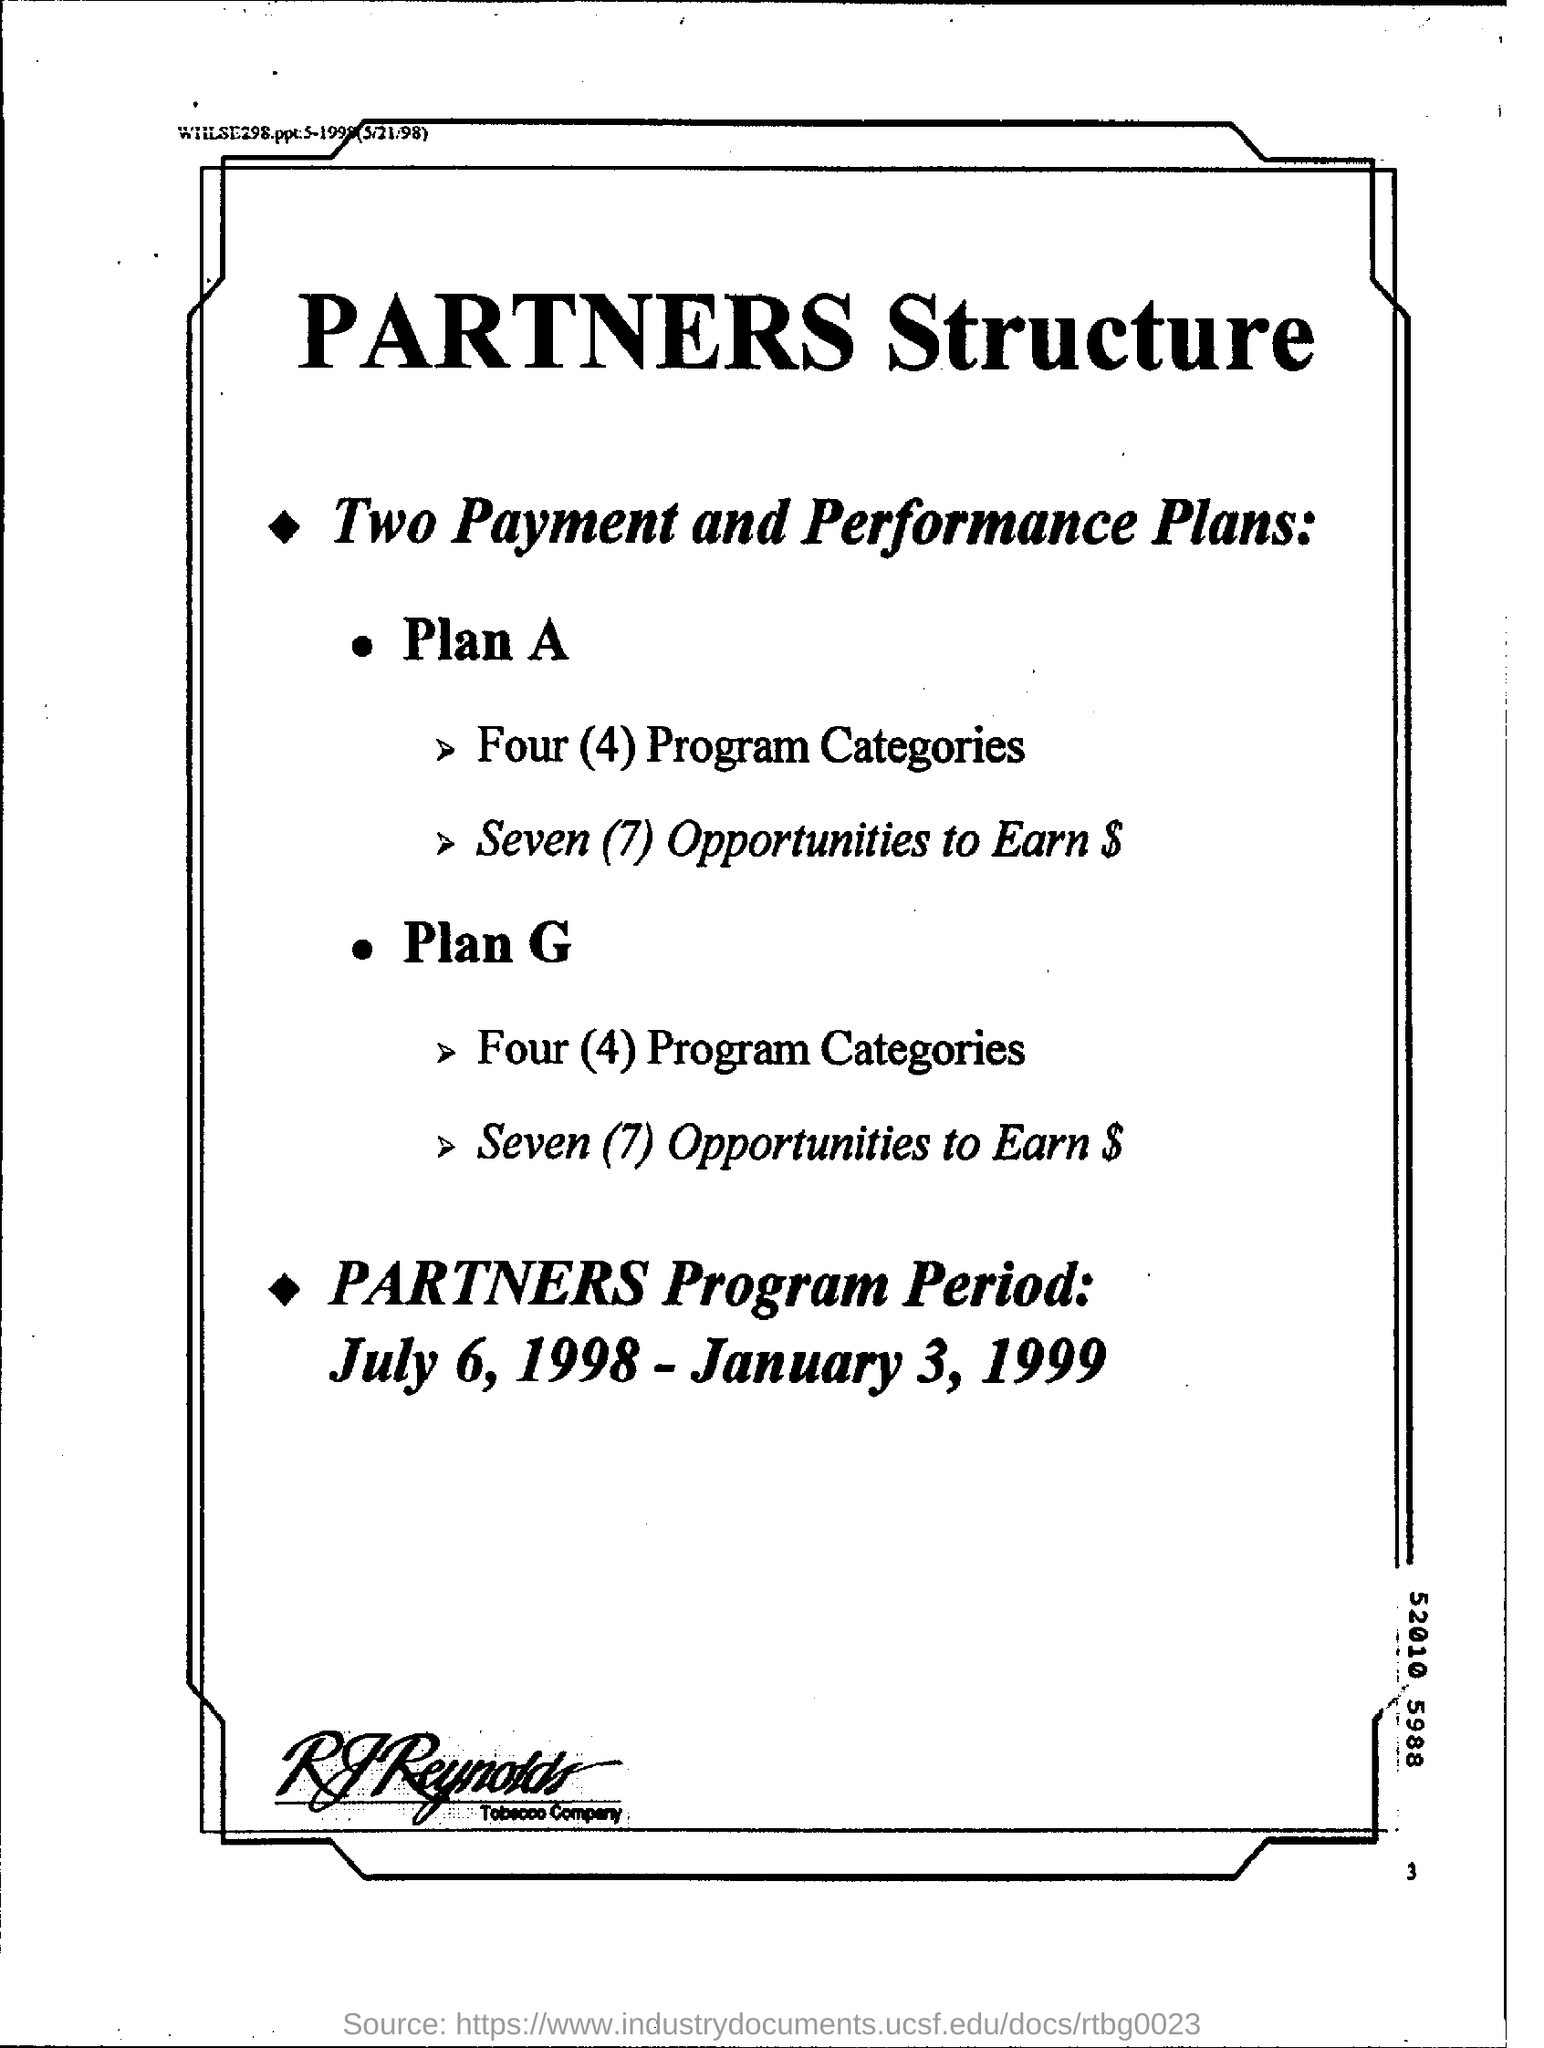How many payment and performance plans are there ?
Provide a succinct answer. Two. What is the number of program categories under plan g?
Offer a terse response. 4. What is the partners program period?
Ensure brevity in your answer.  July 6, 1998 - January 3, 1999. What is the number at bottom right corner of the page ?
Keep it short and to the point. 3. What is the name of the tobacco company?
Offer a very short reply. RJ REYNOLDS. 